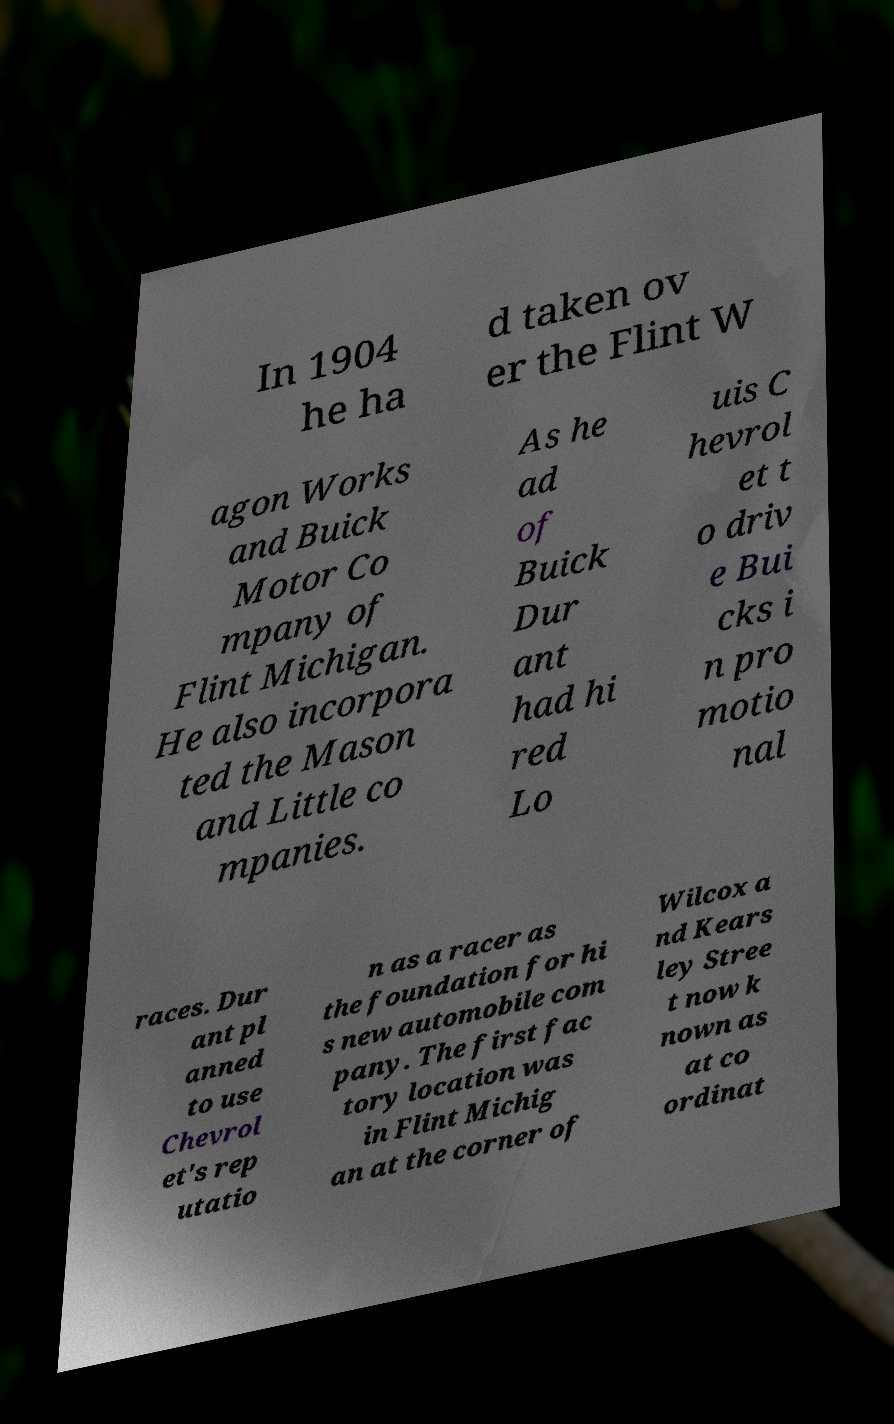For documentation purposes, I need the text within this image transcribed. Could you provide that? In 1904 he ha d taken ov er the Flint W agon Works and Buick Motor Co mpany of Flint Michigan. He also incorpora ted the Mason and Little co mpanies. As he ad of Buick Dur ant had hi red Lo uis C hevrol et t o driv e Bui cks i n pro motio nal races. Dur ant pl anned to use Chevrol et's rep utatio n as a racer as the foundation for hi s new automobile com pany. The first fac tory location was in Flint Michig an at the corner of Wilcox a nd Kears ley Stree t now k nown as at co ordinat 